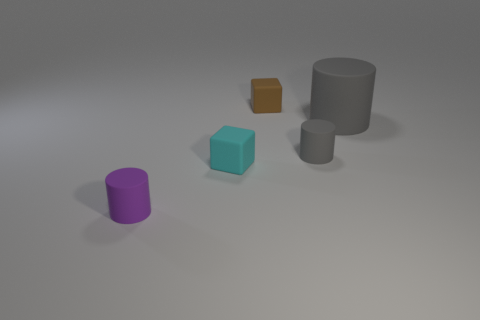Subtract all small gray cylinders. How many cylinders are left? 2 Subtract all blocks. How many objects are left? 3 Add 1 brown objects. How many objects exist? 6 Subtract all gray cylinders. How many cylinders are left? 1 Subtract 0 cyan cylinders. How many objects are left? 5 Subtract 2 blocks. How many blocks are left? 0 Subtract all yellow cylinders. Subtract all brown spheres. How many cylinders are left? 3 Subtract all blue spheres. How many cyan cylinders are left? 0 Subtract all tiny gray rubber objects. Subtract all big blue matte cylinders. How many objects are left? 4 Add 1 tiny cyan objects. How many tiny cyan objects are left? 2 